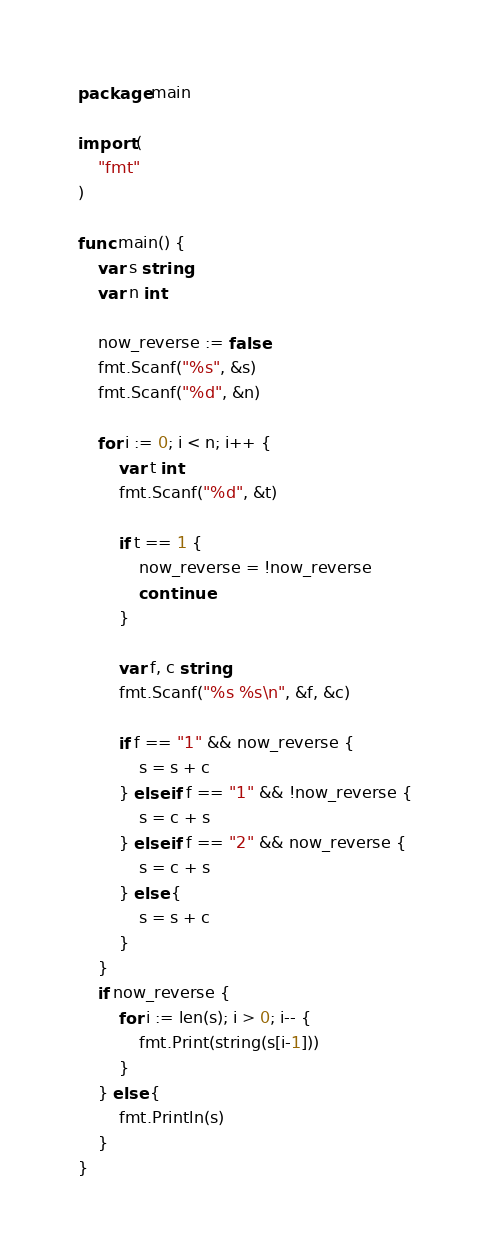Convert code to text. <code><loc_0><loc_0><loc_500><loc_500><_Go_>package main

import (
	"fmt"
)

func main() {
	var s string
	var n int

	now_reverse := false
	fmt.Scanf("%s", &s)
	fmt.Scanf("%d", &n)

	for i := 0; i < n; i++ {
		var t int
		fmt.Scanf("%d", &t)

		if t == 1 {
			now_reverse = !now_reverse
			continue
		}

		var f, c string
		fmt.Scanf("%s %s\n", &f, &c)

		if f == "1" && now_reverse {
			s = s + c
		} else if f == "1" && !now_reverse {
			s = c + s
		} else if f == "2" && now_reverse {
			s = c + s
		} else {
			s = s + c
		}
	}
	if now_reverse {
		for i := len(s); i > 0; i-- {
			fmt.Print(string(s[i-1]))
		}
	} else {
		fmt.Println(s)
	}
}
</code> 